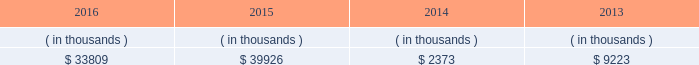System energy resources , inc .
Management 2019s financial discussion and analysis also in addition to the contractual obligations , system energy has $ 382.3 million of unrecognized tax benefits and interest net of unused tax attributes and payments for which the timing of payments beyond 12 months cannot be reasonably estimated due to uncertainties in the timing of effective settlement of tax positions .
See note 3 to the financial statements for additional information regarding unrecognized tax benefits .
In addition to routine spending to maintain operations , the planned capital investment estimate includes specific investments and initiatives such as the nuclear fleet operational excellence initiative , as discussed below in 201cnuclear matters , 201d and plant improvements .
As a wholly-owned subsidiary , system energy dividends its earnings to entergy corporation at a percentage determined monthly .
Sources of capital system energy 2019s sources to meet its capital requirements include : 2022 internally generated funds ; 2022 cash on hand ; 2022 debt issuances ; and 2022 bank financing under new or existing facilities .
System energy may refinance , redeem , or otherwise retire debt prior to maturity , to the extent market conditions and interest and dividend rates are favorable .
All debt and common stock issuances by system energy require prior regulatory approval .
Debt issuances are also subject to issuance tests set forth in its bond indentures and other agreements .
System energy has sufficient capacity under these tests to meet its foreseeable capital needs .
System energy 2019s receivables from the money pool were as follows as of december 31 for each of the following years. .
See note 4 to the financial statements for a description of the money pool .
The system energy nuclear fuel company variable interest entity has a credit facility in the amount of $ 120 million scheduled to expire in may 2019 .
As of december 31 , 2016 , $ 66.9 million in letters of credit were outstanding under the credit facility to support a like amount of commercial paper issued by the system energy nuclear fuel company variable interest entity .
See note 4 to the financial statements for additional discussion of the variable interest entity credit facility .
System energy obtained authorizations from the ferc through october 2017 for the following : 2022 short-term borrowings not to exceed an aggregate amount of $ 200 million at any time outstanding ; 2022 long-term borrowings and security issuances ; and 2022 long-term borrowings by its nuclear fuel company variable interest entity .
See note 4 to the financial statements for further discussion of system energy 2019s short-term borrowing limits. .
What is the percentage change in the system energy 2019s receivables from the money pool from 2015 to 2016? 
Computations: ((33809 - 39926) / 39926)
Answer: -0.15321. 